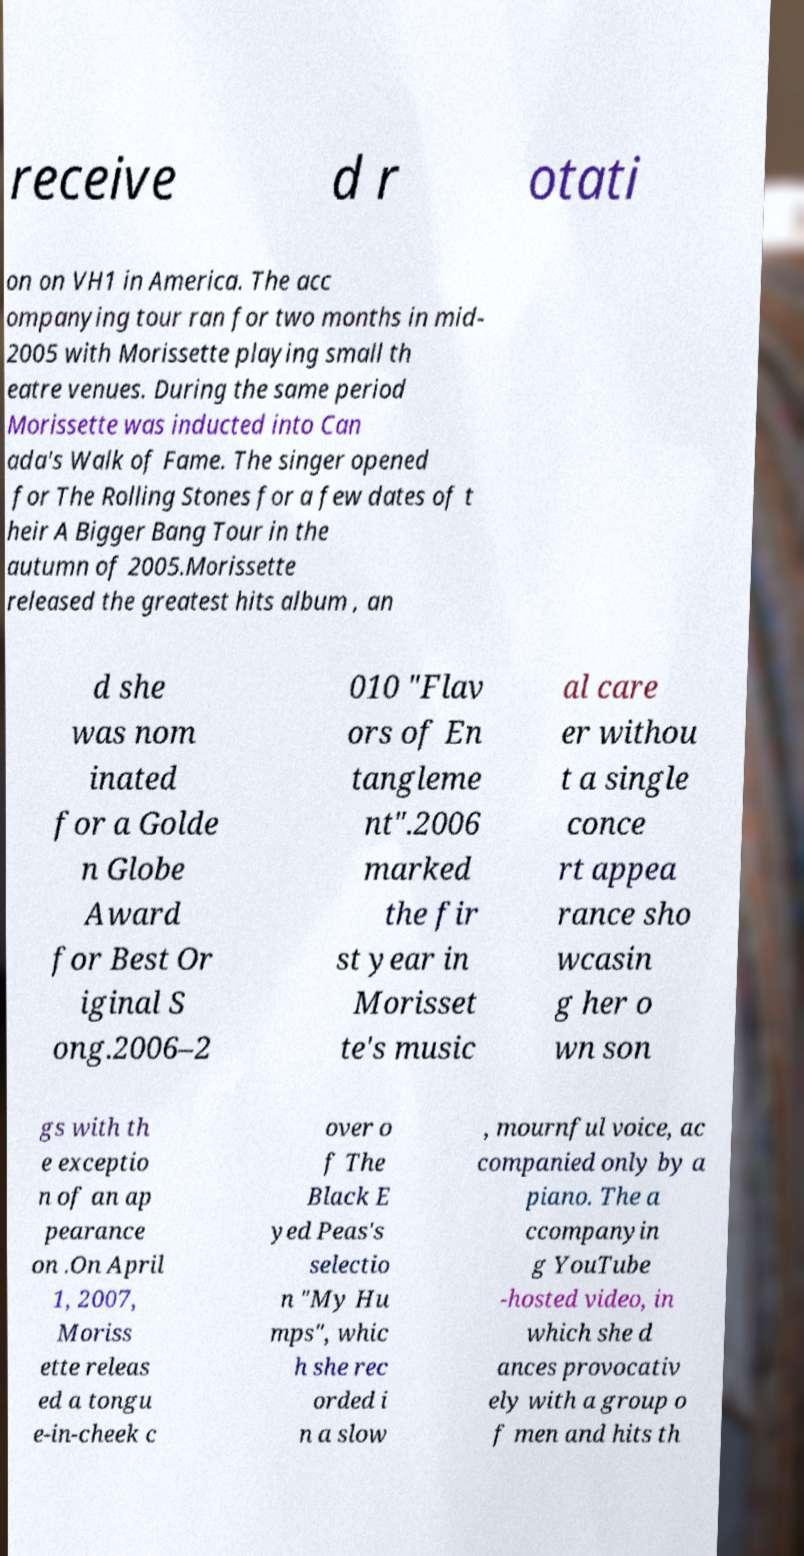What messages or text are displayed in this image? I need them in a readable, typed format. receive d r otati on on VH1 in America. The acc ompanying tour ran for two months in mid- 2005 with Morissette playing small th eatre venues. During the same period Morissette was inducted into Can ada's Walk of Fame. The singer opened for The Rolling Stones for a few dates of t heir A Bigger Bang Tour in the autumn of 2005.Morissette released the greatest hits album , an d she was nom inated for a Golde n Globe Award for Best Or iginal S ong.2006–2 010 "Flav ors of En tangleme nt".2006 marked the fir st year in Morisset te's music al care er withou t a single conce rt appea rance sho wcasin g her o wn son gs with th e exceptio n of an ap pearance on .On April 1, 2007, Moriss ette releas ed a tongu e-in-cheek c over o f The Black E yed Peas's selectio n "My Hu mps", whic h she rec orded i n a slow , mournful voice, ac companied only by a piano. The a ccompanyin g YouTube -hosted video, in which she d ances provocativ ely with a group o f men and hits th 